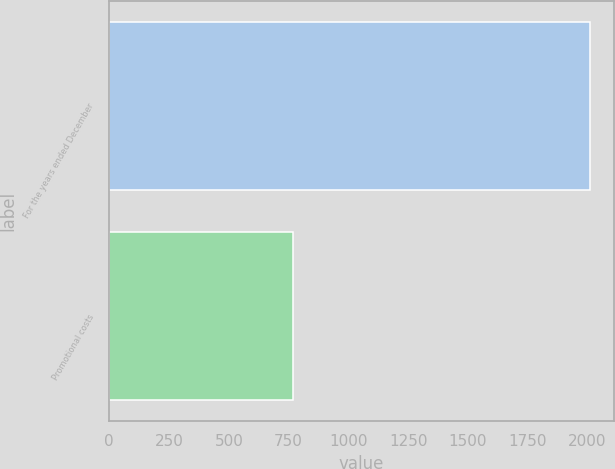Convert chart. <chart><loc_0><loc_0><loc_500><loc_500><bar_chart><fcel>For the years ended December<fcel>Promotional costs<nl><fcel>2010<fcel>767.6<nl></chart> 